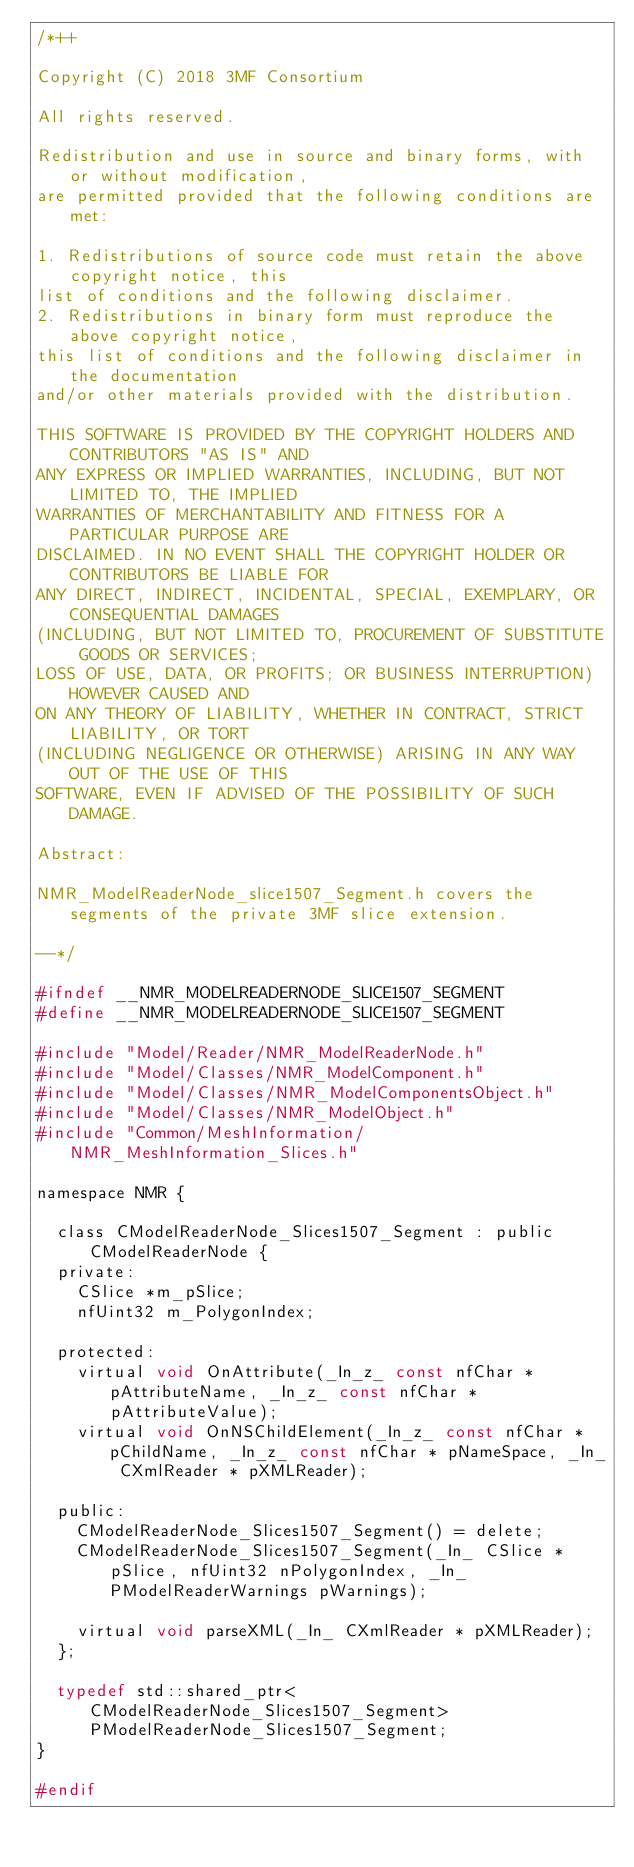<code> <loc_0><loc_0><loc_500><loc_500><_C_>/*++

Copyright (C) 2018 3MF Consortium

All rights reserved.

Redistribution and use in source and binary forms, with or without modification,
are permitted provided that the following conditions are met:

1. Redistributions of source code must retain the above copyright notice, this
list of conditions and the following disclaimer.
2. Redistributions in binary form must reproduce the above copyright notice,
this list of conditions and the following disclaimer in the documentation
and/or other materials provided with the distribution.

THIS SOFTWARE IS PROVIDED BY THE COPYRIGHT HOLDERS AND CONTRIBUTORS "AS IS" AND
ANY EXPRESS OR IMPLIED WARRANTIES, INCLUDING, BUT NOT LIMITED TO, THE IMPLIED
WARRANTIES OF MERCHANTABILITY AND FITNESS FOR A PARTICULAR PURPOSE ARE
DISCLAIMED. IN NO EVENT SHALL THE COPYRIGHT HOLDER OR CONTRIBUTORS BE LIABLE FOR
ANY DIRECT, INDIRECT, INCIDENTAL, SPECIAL, EXEMPLARY, OR CONSEQUENTIAL DAMAGES
(INCLUDING, BUT NOT LIMITED TO, PROCUREMENT OF SUBSTITUTE GOODS OR SERVICES;
LOSS OF USE, DATA, OR PROFITS; OR BUSINESS INTERRUPTION) HOWEVER CAUSED AND
ON ANY THEORY OF LIABILITY, WHETHER IN CONTRACT, STRICT LIABILITY, OR TORT
(INCLUDING NEGLIGENCE OR OTHERWISE) ARISING IN ANY WAY OUT OF THE USE OF THIS
SOFTWARE, EVEN IF ADVISED OF THE POSSIBILITY OF SUCH DAMAGE.

Abstract:

NMR_ModelReaderNode_slice1507_Segment.h covers the segments of the private 3MF slice extension.

--*/

#ifndef __NMR_MODELREADERNODE_SLICE1507_SEGMENT
#define __NMR_MODELREADERNODE_SLICE1507_SEGMENT

#include "Model/Reader/NMR_ModelReaderNode.h"
#include "Model/Classes/NMR_ModelComponent.h"
#include "Model/Classes/NMR_ModelComponentsObject.h"
#include "Model/Classes/NMR_ModelObject.h"
#include "Common/MeshInformation/NMR_MeshInformation_Slices.h"

namespace NMR {

	class CModelReaderNode_Slices1507_Segment : public CModelReaderNode {
	private:
		CSlice *m_pSlice;
		nfUint32 m_PolygonIndex;

	protected:
		virtual void OnAttribute(_In_z_ const nfChar * pAttributeName, _In_z_ const nfChar * pAttributeValue);
		virtual void OnNSChildElement(_In_z_ const nfChar * pChildName, _In_z_ const nfChar * pNameSpace, _In_ CXmlReader * pXMLReader);

	public:
		CModelReaderNode_Slices1507_Segment() = delete;
		CModelReaderNode_Slices1507_Segment(_In_ CSlice *pSlice, nfUint32 nPolygonIndex, _In_ PModelReaderWarnings pWarnings);

		virtual void parseXML(_In_ CXmlReader * pXMLReader);
	};

	typedef std::shared_ptr<CModelReaderNode_Slices1507_Segment> PModelReaderNode_Slices1507_Segment;
}

#endif</code> 